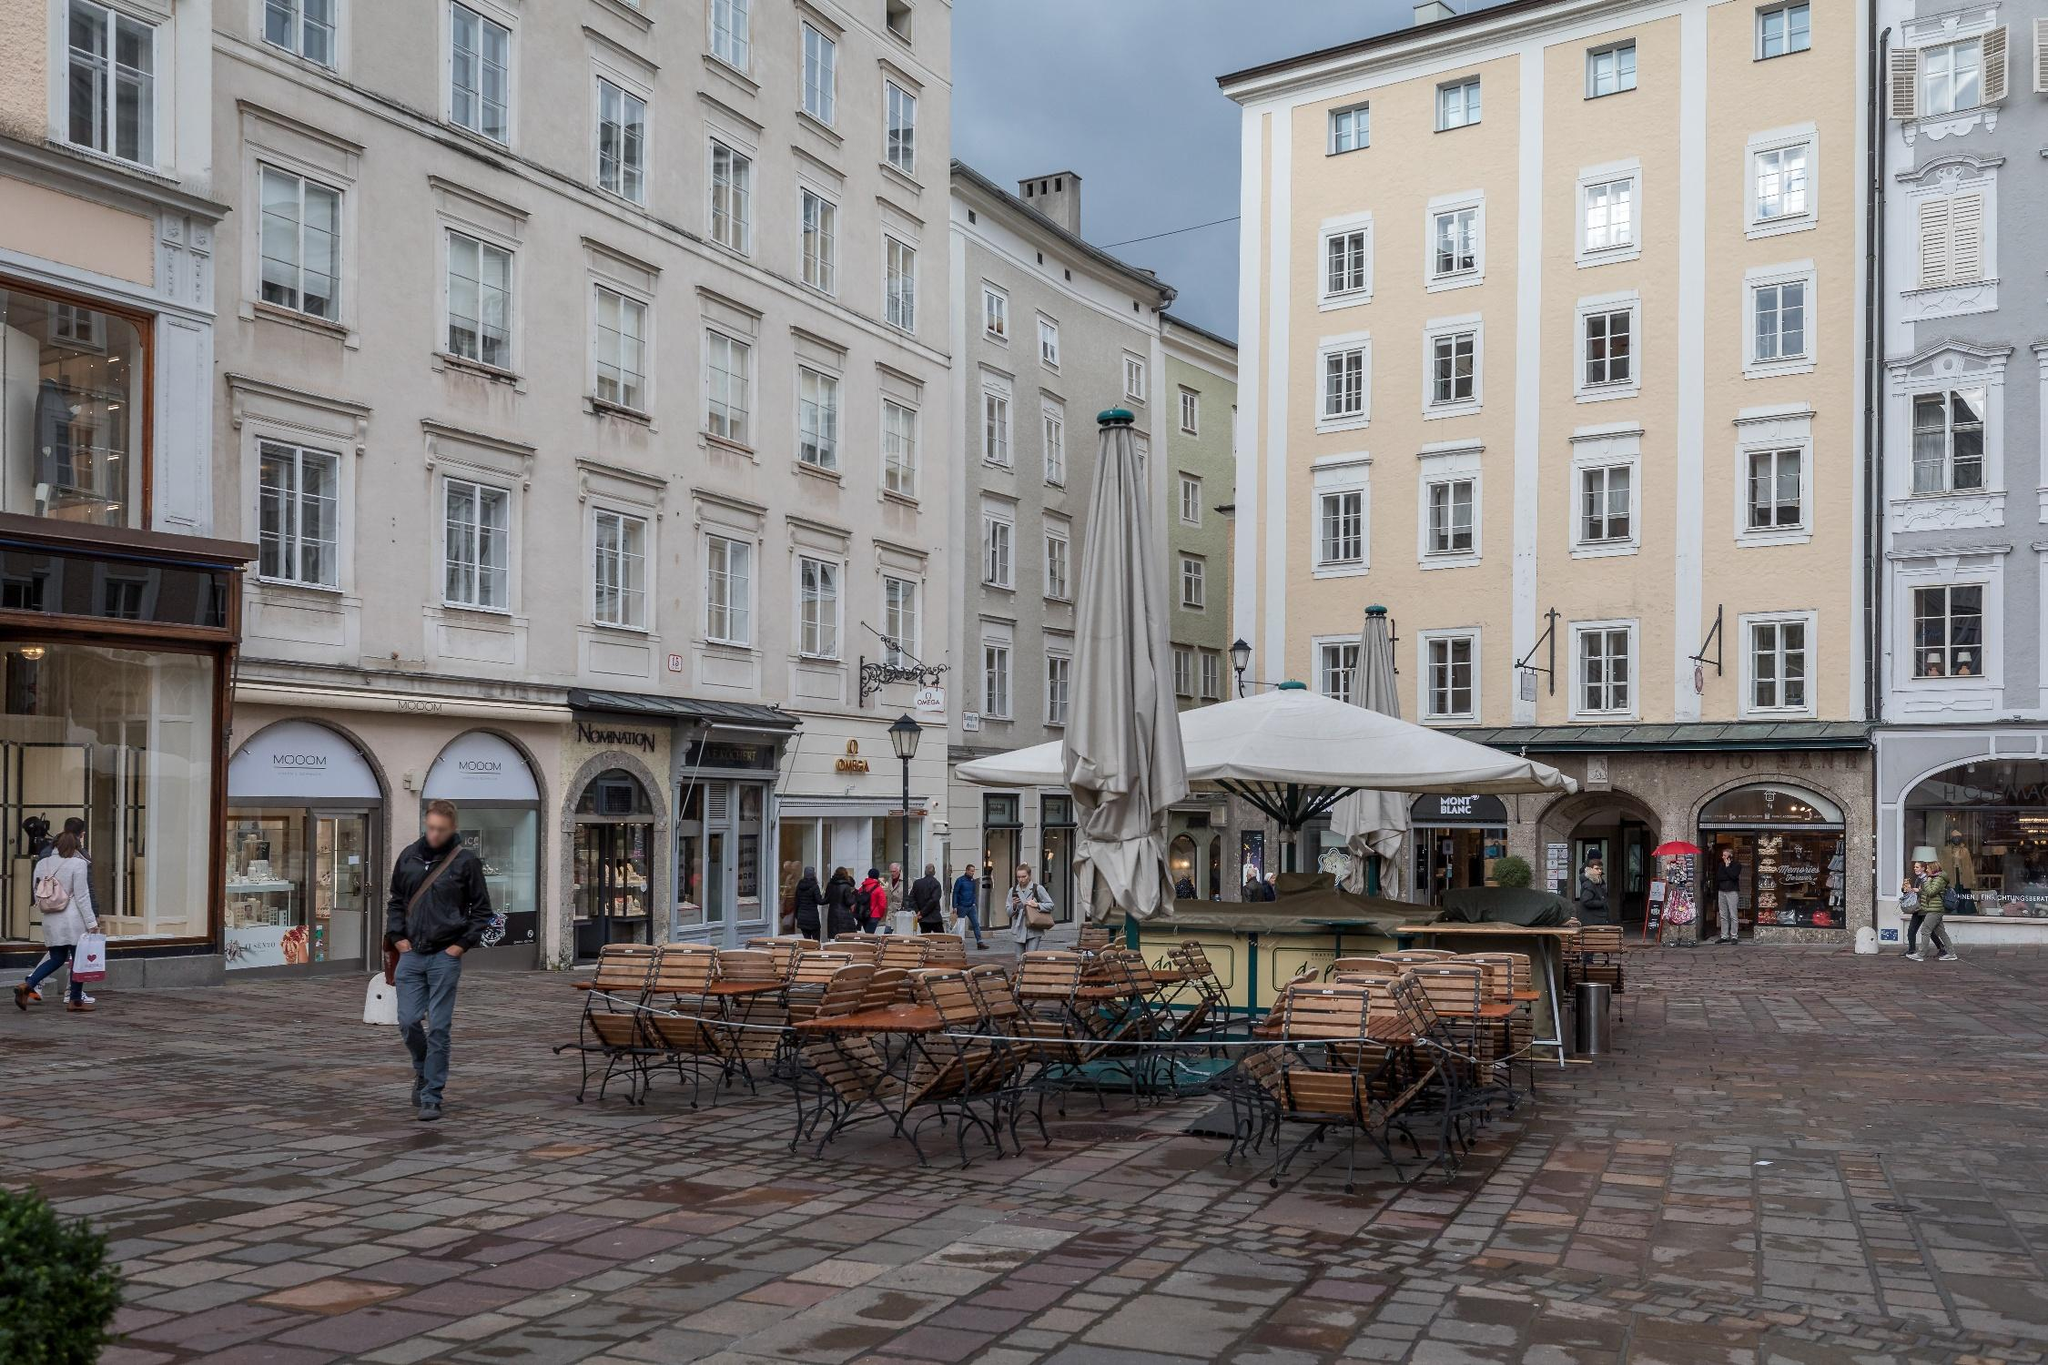Describe a typical day in the life of a shop owner on this street corner. A typical day for a shop owner on this street corner begins early in the morning. They arrive at their shop, greeted by the soft light of dawn casting a gentle glow on the building facades. After unlocking the doors, the shop owner spends time arranging the merchandise, ensuring everything is displayed attractively to catch the eye of passersby. Throughout the day, they welcome a stream of customers, engaging in friendly conversations and providing recommendations. They take breaks at the café, enjoying a cup of coffee while observing the lively street life. The sound of footsteps on cobblestones and the hum of conversations create a vibrant backdrop to their day. As evening falls, they close up shop, feeling content with the day's interactions and sales, and perhaps stop by for a brief chat with neighboring shop owners before heading home. 